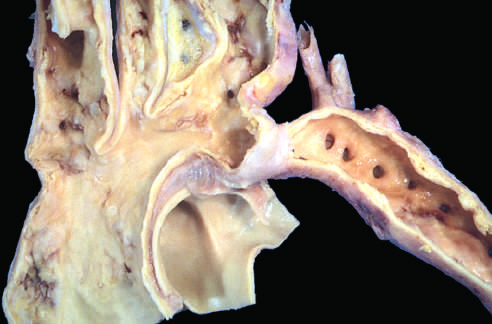re the dilated ascending aorta and major branch vessels to the left of the coarctation?
Answer the question using a single word or phrase. Yes 